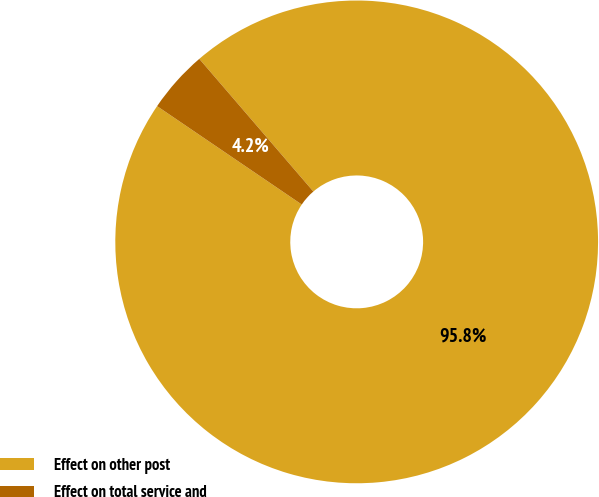<chart> <loc_0><loc_0><loc_500><loc_500><pie_chart><fcel>Effect on other post<fcel>Effect on total service and<nl><fcel>95.81%<fcel>4.19%<nl></chart> 